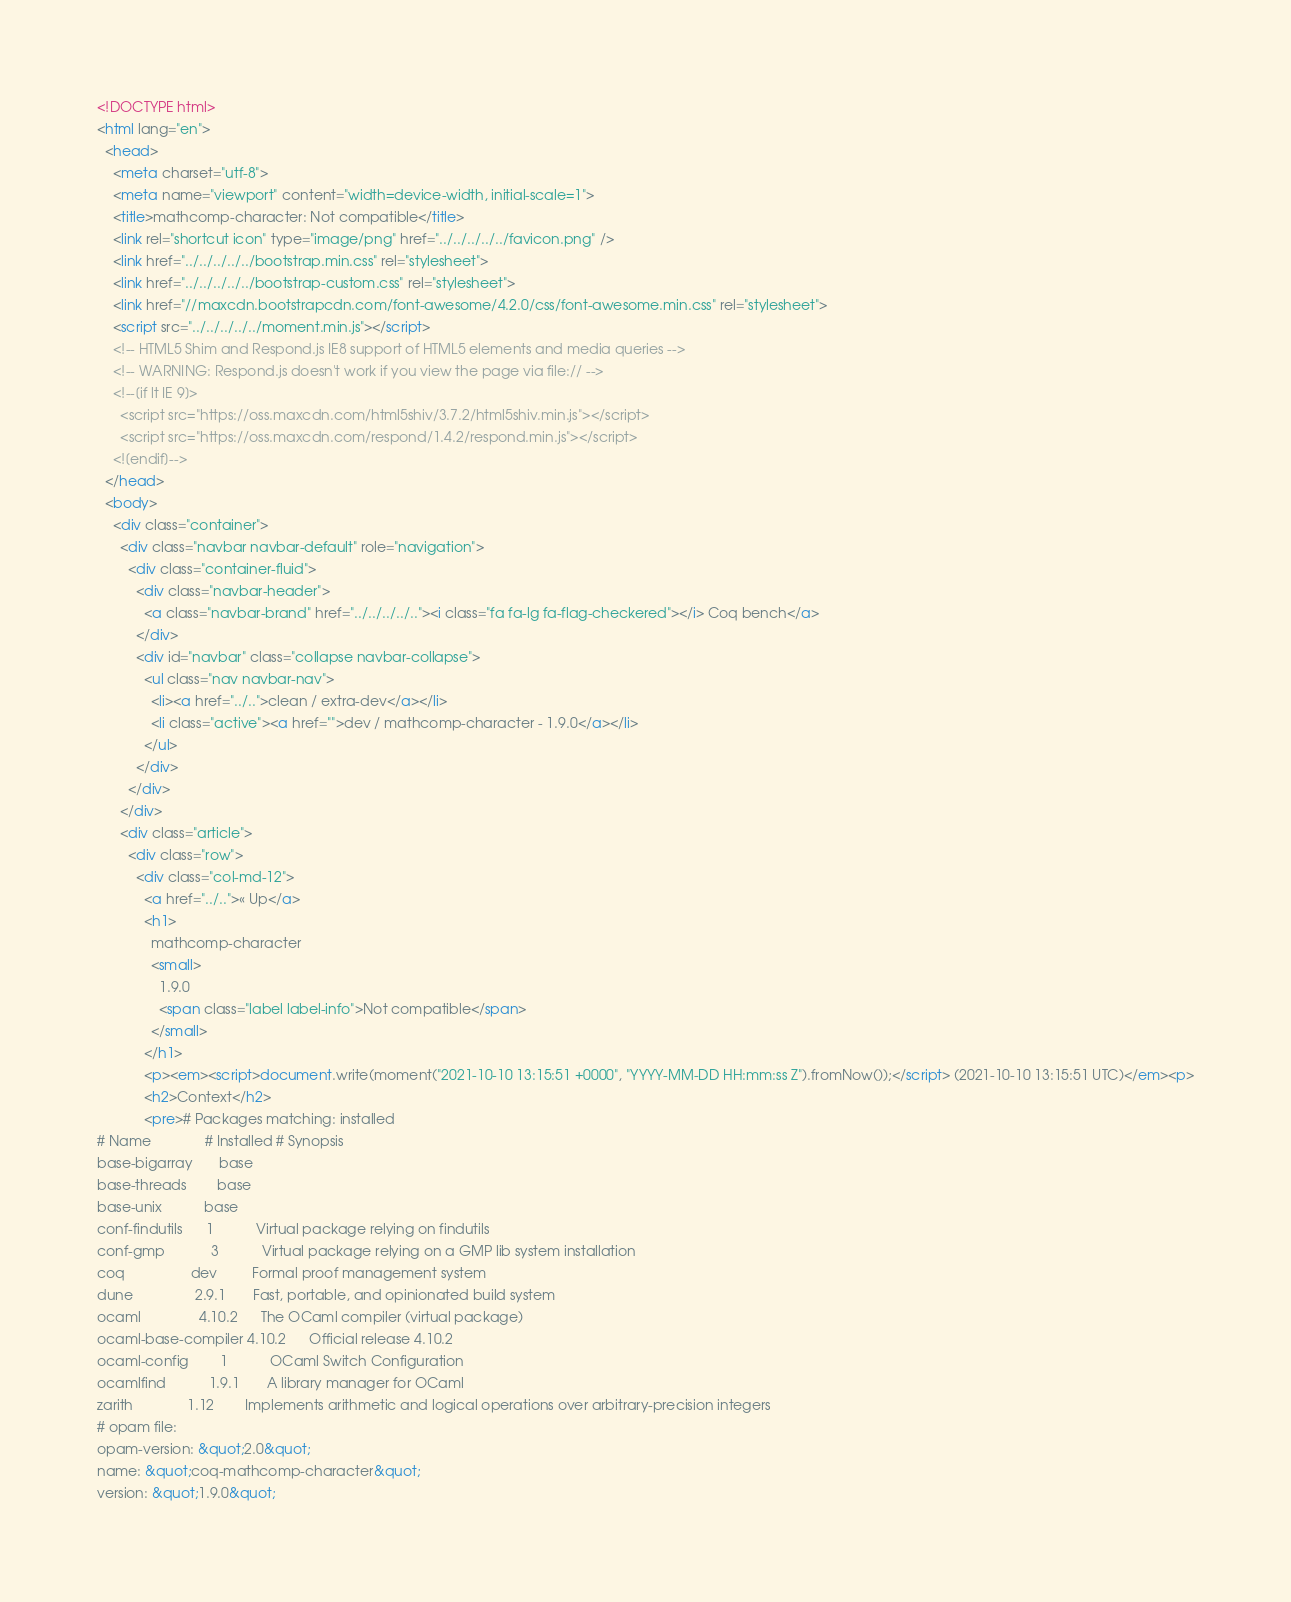Convert code to text. <code><loc_0><loc_0><loc_500><loc_500><_HTML_><!DOCTYPE html>
<html lang="en">
  <head>
    <meta charset="utf-8">
    <meta name="viewport" content="width=device-width, initial-scale=1">
    <title>mathcomp-character: Not compatible</title>
    <link rel="shortcut icon" type="image/png" href="../../../../../favicon.png" />
    <link href="../../../../../bootstrap.min.css" rel="stylesheet">
    <link href="../../../../../bootstrap-custom.css" rel="stylesheet">
    <link href="//maxcdn.bootstrapcdn.com/font-awesome/4.2.0/css/font-awesome.min.css" rel="stylesheet">
    <script src="../../../../../moment.min.js"></script>
    <!-- HTML5 Shim and Respond.js IE8 support of HTML5 elements and media queries -->
    <!-- WARNING: Respond.js doesn't work if you view the page via file:// -->
    <!--[if lt IE 9]>
      <script src="https://oss.maxcdn.com/html5shiv/3.7.2/html5shiv.min.js"></script>
      <script src="https://oss.maxcdn.com/respond/1.4.2/respond.min.js"></script>
    <![endif]-->
  </head>
  <body>
    <div class="container">
      <div class="navbar navbar-default" role="navigation">
        <div class="container-fluid">
          <div class="navbar-header">
            <a class="navbar-brand" href="../../../../.."><i class="fa fa-lg fa-flag-checkered"></i> Coq bench</a>
          </div>
          <div id="navbar" class="collapse navbar-collapse">
            <ul class="nav navbar-nav">
              <li><a href="../..">clean / extra-dev</a></li>
              <li class="active"><a href="">dev / mathcomp-character - 1.9.0</a></li>
            </ul>
          </div>
        </div>
      </div>
      <div class="article">
        <div class="row">
          <div class="col-md-12">
            <a href="../..">« Up</a>
            <h1>
              mathcomp-character
              <small>
                1.9.0
                <span class="label label-info">Not compatible</span>
              </small>
            </h1>
            <p><em><script>document.write(moment("2021-10-10 13:15:51 +0000", "YYYY-MM-DD HH:mm:ss Z").fromNow());</script> (2021-10-10 13:15:51 UTC)</em><p>
            <h2>Context</h2>
            <pre># Packages matching: installed
# Name              # Installed # Synopsis
base-bigarray       base
base-threads        base
base-unix           base
conf-findutils      1           Virtual package relying on findutils
conf-gmp            3           Virtual package relying on a GMP lib system installation
coq                 dev         Formal proof management system
dune                2.9.1       Fast, portable, and opinionated build system
ocaml               4.10.2      The OCaml compiler (virtual package)
ocaml-base-compiler 4.10.2      Official release 4.10.2
ocaml-config        1           OCaml Switch Configuration
ocamlfind           1.9.1       A library manager for OCaml
zarith              1.12        Implements arithmetic and logical operations over arbitrary-precision integers
# opam file:
opam-version: &quot;2.0&quot;
name: &quot;coq-mathcomp-character&quot;
version: &quot;1.9.0&quot;</code> 